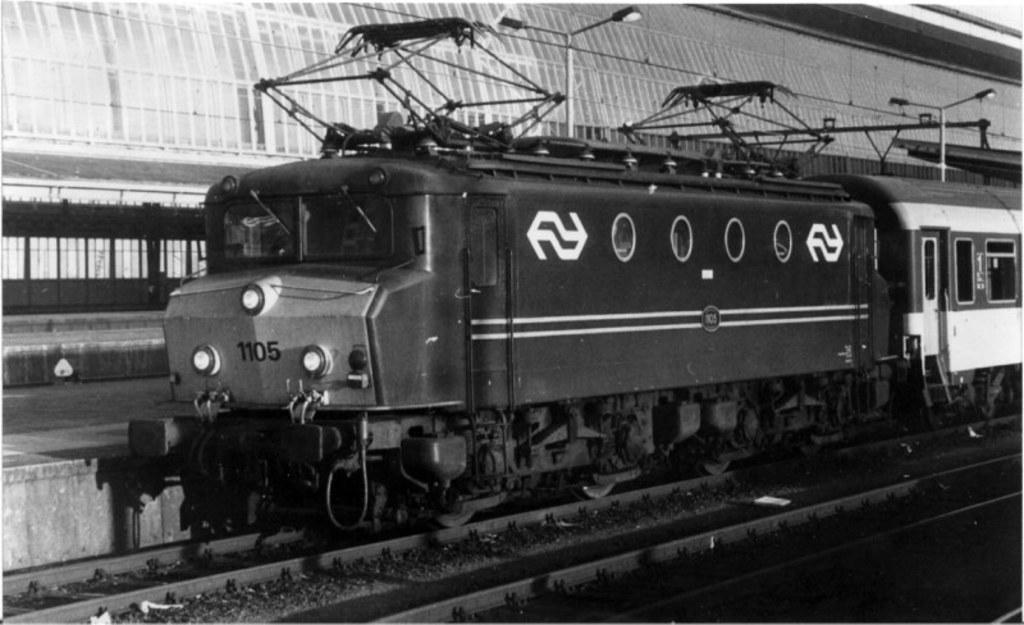What is the main subject of the image? The main subject of the image is a train. Where is the train located in the image? The train is on a track. What can be seen at the bottom of the image? There are tracks visible at the bottom of the image. What structures are visible in the background of the image? There is a platform, a shed, and poles visible in the background of the image. What is visible at the top of the image? There are lights visible at the top of the image. What type of list can be seen hanging on the train in the image? There is no list visible on the train in the image. What type of salt is being used to clean the tracks in the image? There is no salt being used to clean the tracks in the image; the tracks are simply visible at the bottom of the image. 